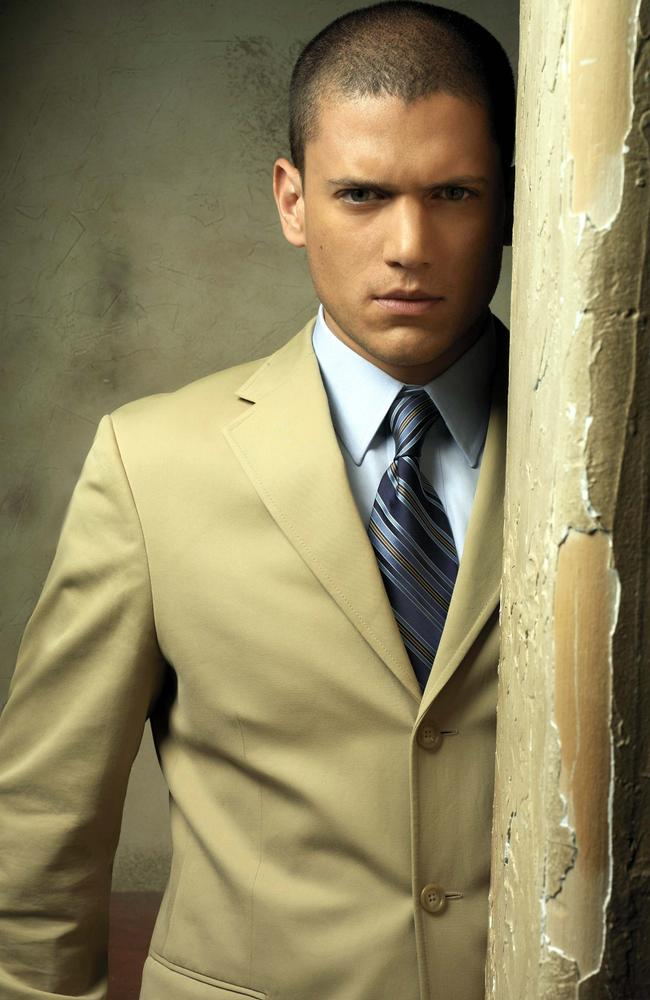Imagine the wall in the image could talk. What stories would it tell? If the wall could talk, it would whisper tales of history and transformation. Once painted in bright colors, it witnessed the laughter and tears of families who lived there. It stood strong as the neighborhood changed, adapting to the seasons and the passage of time. People leaned on it during their most vulnerable moments, and it silently offered support. Now, as it sheds its old paint, it doesn't just reveal a rustic charm but layers upon layers of human experience, etched into its very being. 